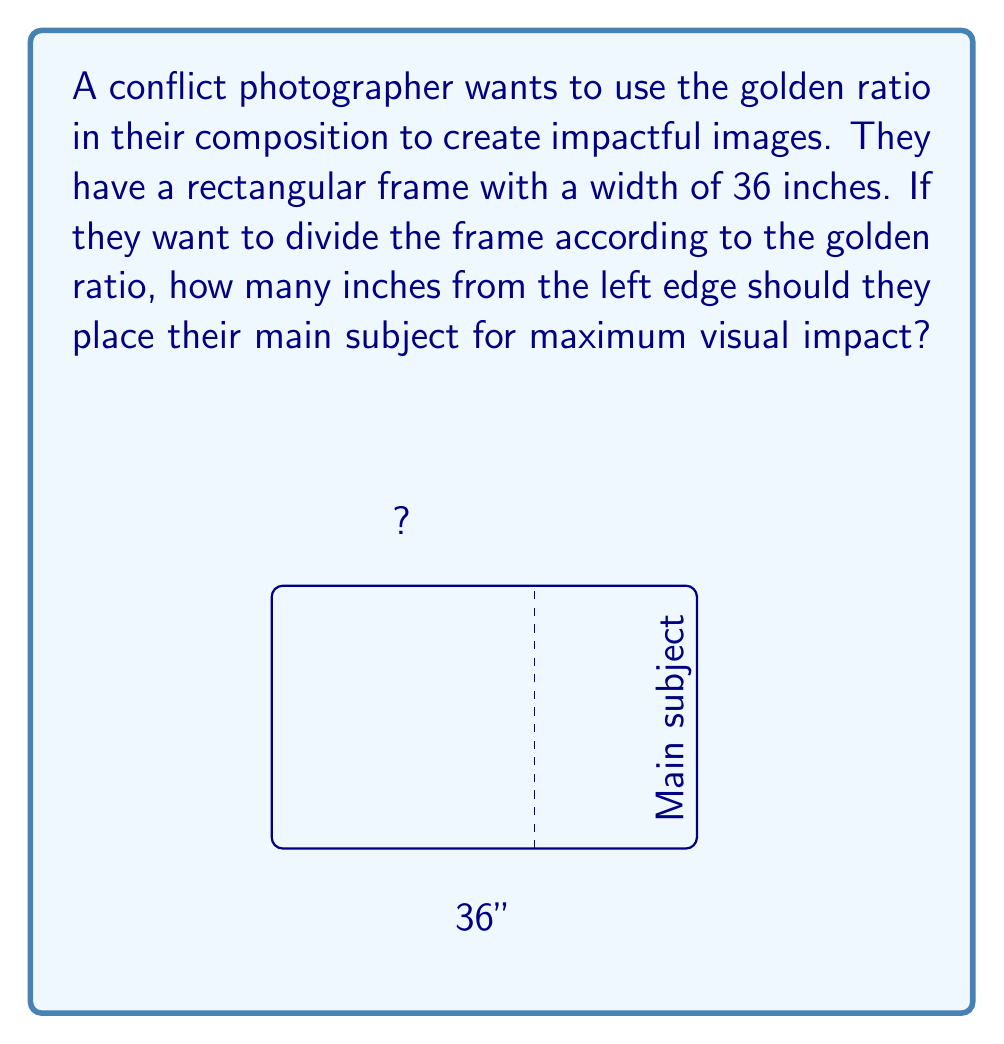What is the answer to this math problem? To solve this problem, we need to use the properties of the golden ratio. The golden ratio, denoted by φ (phi), is approximately equal to 1.618033988749895.

Step 1: Recall the golden ratio property
In a line segment divided according to the golden ratio, the ratio of the whole length to the longer segment is equal to the ratio of the longer segment to the shorter segment.

Step 2: Set up the equation
Let x be the distance from the left edge where the main subject should be placed.
Then, we can write the golden ratio equation as:

$$ \frac{36}{x} = \frac{x}{36-x} = φ $$

Step 3: Solve for x
We can rewrite this as a quadratic equation:

$$ x^2 = 36(36-x) $$
$$ x^2 = 1296 - 36x $$
$$ x^2 + 36x - 1296 = 0 $$

Step 4: Use the quadratic formula
$$ x = \frac{-b \pm \sqrt{b^2 - 4ac}}{2a} $$

Where a = 1, b = 36, and c = -1296

$$ x = \frac{-36 \pm \sqrt{36^2 - 4(1)(-1296)}}{2(1)} $$
$$ x = \frac{-36 \pm \sqrt{1296 + 5184}}{2} $$
$$ x = \frac{-36 \pm \sqrt{6480}}{2} $$
$$ x = \frac{-36 \pm 80.5}{2} $$

Step 5: Choose the positive solution
$$ x = \frac{-36 + 80.5}{2} = 22.25 $$

Therefore, the photographer should place the main subject approximately 22.25 inches from the left edge of the frame to achieve the golden ratio composition.
Answer: 22.25 inches 